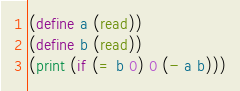<code> <loc_0><loc_0><loc_500><loc_500><_Scheme_>(define a (read))
(define b (read))
(print (if (= b 0) 0 (- a b)))</code> 